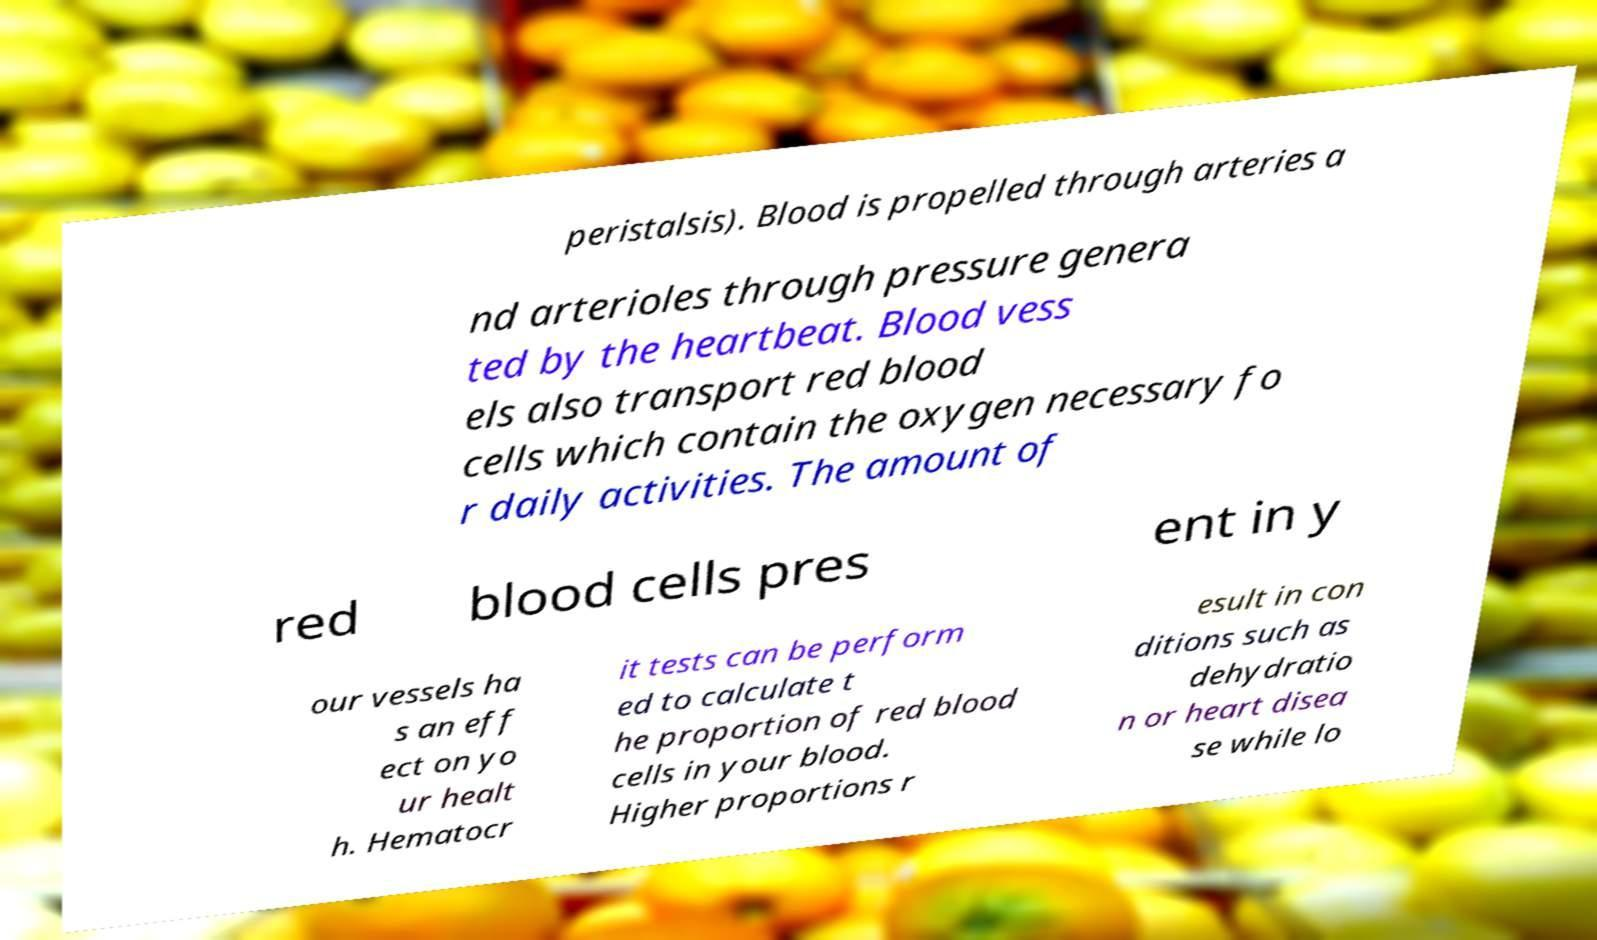Could you assist in decoding the text presented in this image and type it out clearly? peristalsis). Blood is propelled through arteries a nd arterioles through pressure genera ted by the heartbeat. Blood vess els also transport red blood cells which contain the oxygen necessary fo r daily activities. The amount of red blood cells pres ent in y our vessels ha s an eff ect on yo ur healt h. Hematocr it tests can be perform ed to calculate t he proportion of red blood cells in your blood. Higher proportions r esult in con ditions such as dehydratio n or heart disea se while lo 